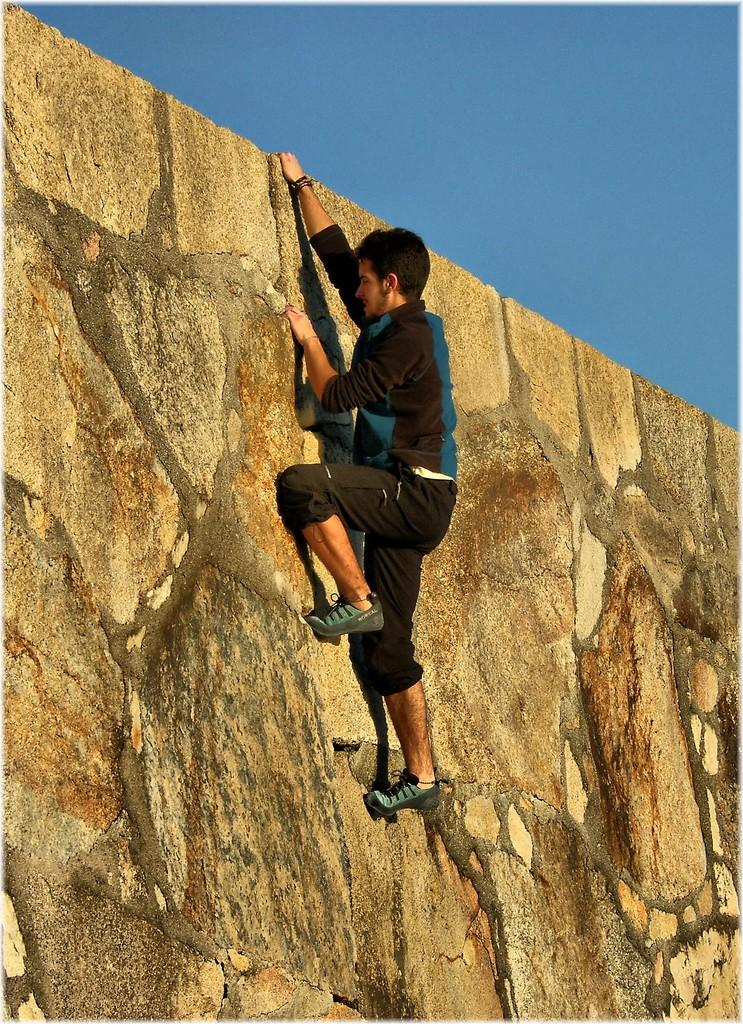What is happening in the image? There is a person in the image who is climbing a wall. What can be seen in the background of the image? The sky is visible at the top of the image. What type of drug is the person taking while climbing the wall in the image? There is no indication in the image that the person is taking any drug, and therefore no such activity can be observed. 